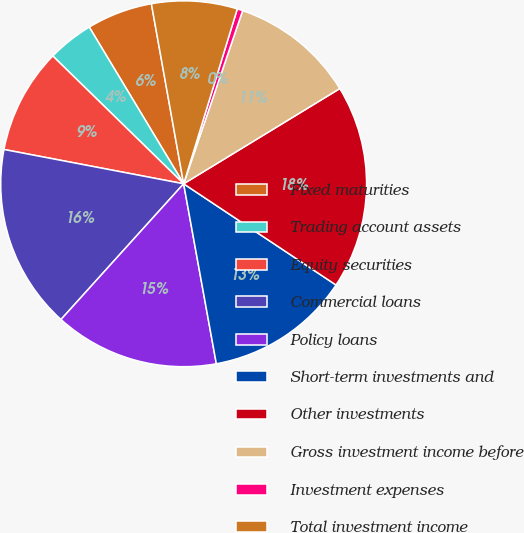<chart> <loc_0><loc_0><loc_500><loc_500><pie_chart><fcel>Fixed maturities<fcel>Trading account assets<fcel>Equity securities<fcel>Commercial loans<fcel>Policy loans<fcel>Short-term investments and<fcel>Other investments<fcel>Gross investment income before<fcel>Investment expenses<fcel>Total investment income<nl><fcel>5.81%<fcel>4.06%<fcel>9.31%<fcel>16.31%<fcel>14.56%<fcel>12.81%<fcel>18.05%<fcel>11.06%<fcel>0.49%<fcel>7.56%<nl></chart> 